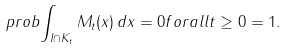Convert formula to latex. <formula><loc_0><loc_0><loc_500><loc_500>\ p r o b { \int _ { I \cap K _ { t } } M _ { t } ( x ) \, d x = 0 f o r a l l t \geq 0 } = 1 .</formula> 